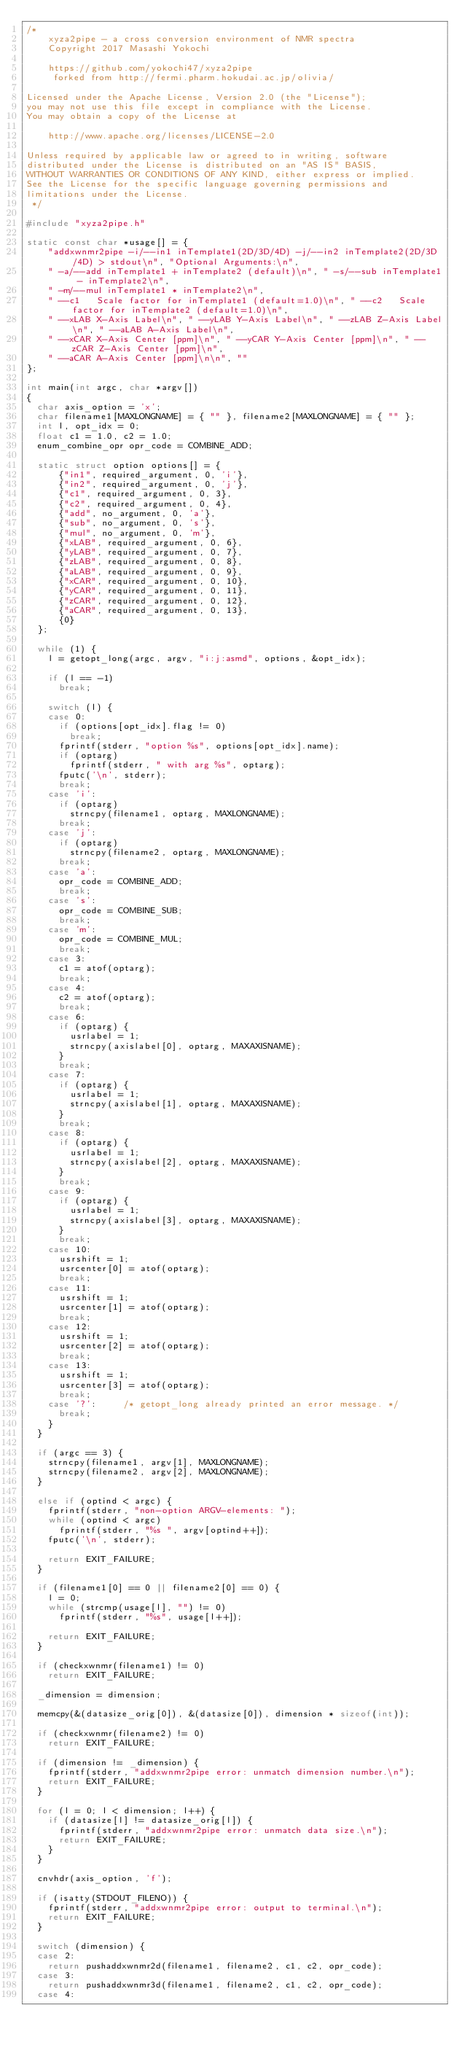Convert code to text. <code><loc_0><loc_0><loc_500><loc_500><_C_>/*
    xyza2pipe - a cross conversion environment of NMR spectra
    Copyright 2017 Masashi Yokochi

    https://github.com/yokochi47/xyza2pipe
     forked from http://fermi.pharm.hokudai.ac.jp/olivia/

Licensed under the Apache License, Version 2.0 (the "License");
you may not use this file except in compliance with the License.
You may obtain a copy of the License at

    http://www.apache.org/licenses/LICENSE-2.0

Unless required by applicable law or agreed to in writing, software
distributed under the License is distributed on an "AS IS" BASIS,
WITHOUT WARRANTIES OR CONDITIONS OF ANY KIND, either express or implied.
See the License for the specific language governing permissions and
limitations under the License.
 */

#include "xyza2pipe.h"

static const char *usage[] = {
		"addxwnmr2pipe -i/--in1 inTemplate1(2D/3D/4D) -j/--in2 inTemplate2(2D/3D/4D) > stdout\n", "Optional Arguments:\n",
		" -a/--add inTemplate1 + inTemplate2 (default)\n", " -s/--sub inTemplate1 - inTemplate2\n",
		" -m/--mul inTemplate1 * inTemplate2\n",
		" --c1   Scale factor for inTemplate1 (default=1.0)\n", " --c2   Scale factor for inTemplate2 (default=1.0)\n",
		" --xLAB X-Axis Label\n", " --yLAB Y-Axis Label\n", " --zLAB Z-Axis Label\n", " --aLAB A-Axis Label\n",
		" --xCAR X-Axis Center [ppm]\n", " --yCAR Y-Axis Center [ppm]\n", " --zCAR Z-Axis Center [ppm]\n",
		" --aCAR A-Axis Center [ppm]\n\n", ""
};

int main(int argc, char *argv[])
{
	char axis_option = 'x';
	char filename1[MAXLONGNAME] = { "" }, filename2[MAXLONGNAME] = { "" };
	int l, opt_idx = 0;
	float c1 = 1.0, c2 = 1.0;
	enum_combine_opr opr_code = COMBINE_ADD;

	static struct option options[] = {
			{"in1", required_argument, 0, 'i'},
			{"in2", required_argument, 0, 'j'},
			{"c1", required_argument, 0, 3},
			{"c2", required_argument, 0, 4},
			{"add", no_argument, 0, 'a'},
			{"sub", no_argument, 0, 's'},
			{"mul", no_argument, 0, 'm'},
			{"xLAB", required_argument, 0, 6},
			{"yLAB", required_argument, 0, 7},
			{"zLAB", required_argument, 0, 8},
			{"aLAB", required_argument, 0, 9},
			{"xCAR", required_argument, 0, 10},
			{"yCAR", required_argument, 0, 11},
			{"zCAR", required_argument, 0, 12},
			{"aCAR", required_argument, 0, 13},
			{0}
	};

	while (1) {
		l = getopt_long(argc, argv, "i:j:asmd", options, &opt_idx);

		if (l == -1)
			break;

		switch (l) {
		case 0:
			if (options[opt_idx].flag != 0)
				break;
			fprintf(stderr, "option %s", options[opt_idx].name);
			if (optarg)
				fprintf(stderr, " with arg %s", optarg);
			fputc('\n', stderr);
			break;
		case 'i':
			if (optarg)
				strncpy(filename1, optarg, MAXLONGNAME);
			break;
		case 'j':
			if (optarg)
				strncpy(filename2, optarg, MAXLONGNAME);
			break;
		case 'a':
			opr_code = COMBINE_ADD;
			break;
		case 's':
			opr_code = COMBINE_SUB;
			break;
		case 'm':
			opr_code = COMBINE_MUL;
			break;
		case 3:
			c1 = atof(optarg);
			break;
		case 4:
			c2 = atof(optarg);
			break;
		case 6:
			if (optarg) {
				usrlabel = 1;
				strncpy(axislabel[0], optarg, MAXAXISNAME);
			}
			break;
		case 7:
			if (optarg) {
				usrlabel = 1;
				strncpy(axislabel[1], optarg, MAXAXISNAME);
			}
			break;
		case 8:
			if (optarg) {
				usrlabel = 1;
				strncpy(axislabel[2], optarg, MAXAXISNAME);
			}
			break;
		case 9:
			if (optarg) {
				usrlabel = 1;
				strncpy(axislabel[3], optarg, MAXAXISNAME);
			}
			break;
		case 10:
			usrshift = 1;
			usrcenter[0] = atof(optarg);
			break;
		case 11:
			usrshift = 1;
			usrcenter[1] = atof(optarg);
			break;
		case 12:
			usrshift = 1;
			usrcenter[2] = atof(optarg);
			break;
		case 13:
			usrshift = 1;
			usrcenter[3] = atof(optarg);
			break;
		case '?':			/* getopt_long already printed an error message. */
			break;
		}
	}

	if (argc == 3) {
		strncpy(filename1, argv[1], MAXLONGNAME);
		strncpy(filename2, argv[2], MAXLONGNAME);
	}

	else if (optind < argc) {
		fprintf(stderr, "non-option ARGV-elements: ");
		while (optind < argc)
			fprintf(stderr, "%s ", argv[optind++]);
		fputc('\n', stderr);

		return EXIT_FAILURE;
	}

	if (filename1[0] == 0 || filename2[0] == 0) {
		l = 0;
		while (strcmp(usage[l], "") != 0)
			fprintf(stderr, "%s", usage[l++]);

		return EXIT_FAILURE;
	}

	if (checkxwnmr(filename1) != 0)
		return EXIT_FAILURE;

	_dimension = dimension;

	memcpy(&(datasize_orig[0]), &(datasize[0]), dimension * sizeof(int));

	if (checkxwnmr(filename2) != 0)
		return EXIT_FAILURE;

	if (dimension != _dimension) {
		fprintf(stderr, "addxwnmr2pipe error: unmatch dimension number.\n");
		return EXIT_FAILURE;
	}

	for (l = 0; l < dimension; l++) {
		if (datasize[l] != datasize_orig[l]) {
			fprintf(stderr, "addxwnmr2pipe error: unmatch data size.\n");
			return EXIT_FAILURE;
		}
	}

	cnvhdr(axis_option, 'f');

	if (isatty(STDOUT_FILENO)) {
		fprintf(stderr, "addxwnmr2pipe error: output to terminal.\n");
		return EXIT_FAILURE;
	}

	switch (dimension) {
	case 2:
		return pushaddxwnmr2d(filename1, filename2, c1, c2, opr_code);
	case 3:
		return pushaddxwnmr3d(filename1, filename2, c1, c2, opr_code);
	case 4:</code> 